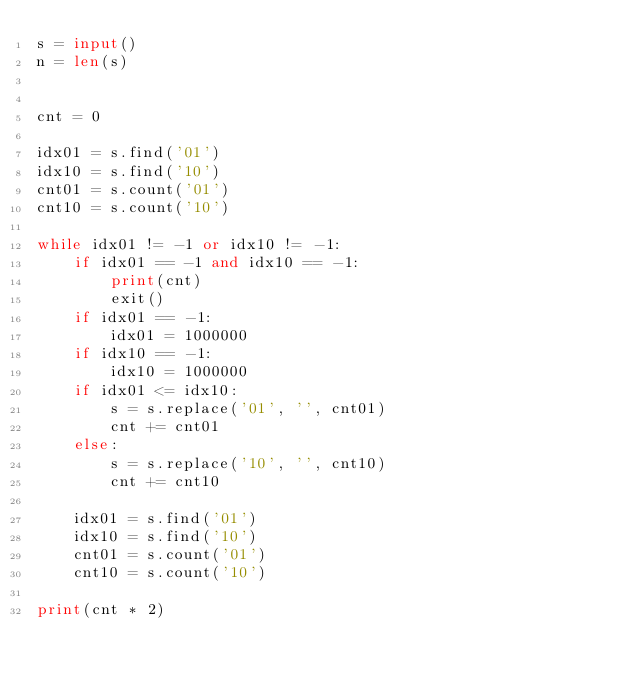<code> <loc_0><loc_0><loc_500><loc_500><_Python_>s = input()
n = len(s)


cnt = 0

idx01 = s.find('01')
idx10 = s.find('10')
cnt01 = s.count('01')
cnt10 = s.count('10')

while idx01 != -1 or idx10 != -1:
    if idx01 == -1 and idx10 == -1:
        print(cnt)
        exit()
    if idx01 == -1:
        idx01 = 1000000
    if idx10 == -1:
        idx10 = 1000000
    if idx01 <= idx10:
        s = s.replace('01', '', cnt01)
        cnt += cnt01
    else:
        s = s.replace('10', '', cnt10)
        cnt += cnt10

    idx01 = s.find('01')
    idx10 = s.find('10')
    cnt01 = s.count('01')
    cnt10 = s.count('10')

print(cnt * 2)</code> 